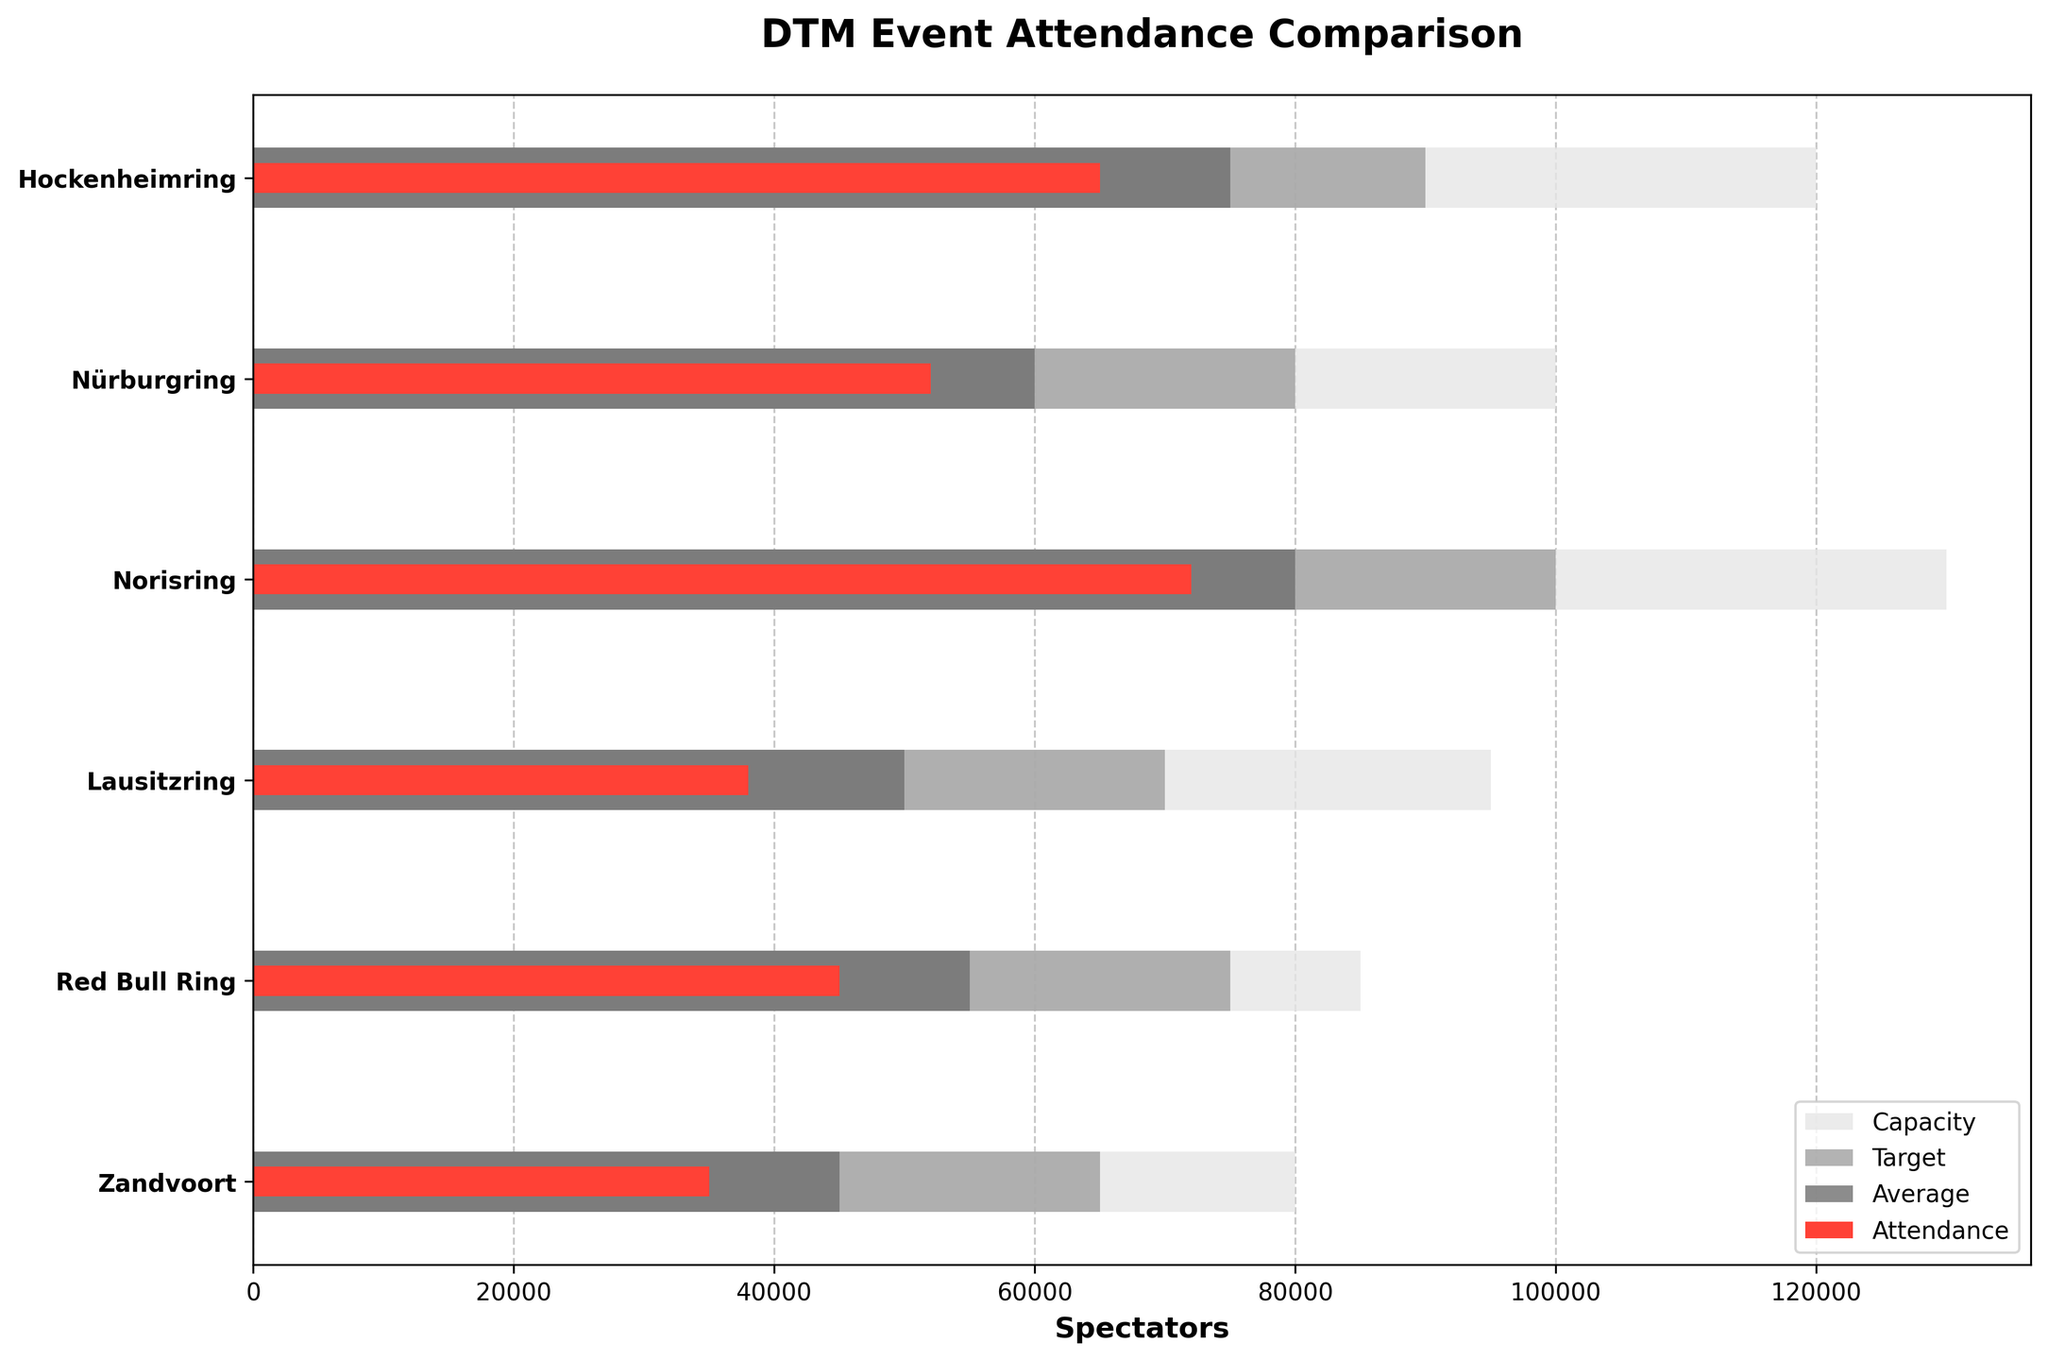What is the title of the figure? The title is located at the top of the figure. From the data provided, it is "DTM Event Attendance Comparison."
Answer: DTM Event Attendance Comparison Which track had the highest attendance? By comparing the lengths of the red bars representing attendance, the longest red bar corresponds to Norisring with an attendance of 72,000.
Answer: Norisring What is the attendance difference between Hockenheimring and Zandvoort? Hockenheimring has an attendance of 65,000, and Zandvoort has 35,000. The difference is calculated as 65,000 - 35,000 = 30,000.
Answer: 30,000 Which track has the smallest difference between average attendance and target attendance? For each track, subtract the average attendance from the target attendance. The smallest difference is observed for Norisring, which has targets and averages closest to each other: 100,000 - 80,000 = 20,000.
Answer: Norisring How does attendance at the Red Bull Ring compare to its capacity? The attendance bar (45,000) is compared to the capacity bar (85,000). The attendance is roughly half of the capacity.
Answer: Less than half Which track has the largest difference between its capacity and attendance? Subtract attendance from capacity for each track and find the maximum value. Lausitzring has the largest difference: 95,000 (capacity) - 38,000 (attendance) = 57,000.
Answer: Lausitzring How many tracks have an average attendance higher than 50,000? Identify the tracks with an average attendance above 50,000: Hockenheimring, Nürburgring, Norisring, and Red Bull Ring. There are 4 tracks meeting this criterion.
Answer: 4 What's the median average attendance across the tracks? The average attendances are: 75,000, 60,000, 80,000, 50,000, 55,000, and 45,000. Arrange them in ascending order: 45,000, 50,000, 55,000, 60,000, 75,000, 80,000. Since there are 6 values, the median is the average of the 3rd and 4th values: (55,000 + 60,000) / 2 = 57,500.
Answer: 57,500 Which track most closely matches its target attendance? Compare attendance to target attendance for each track. Hockenheimring has attendance of 65,000 and a target of 90,000, which is not the closest match. The answer is Norisring with attendance 72,000 and target 100,000.
Answer: Norisring 